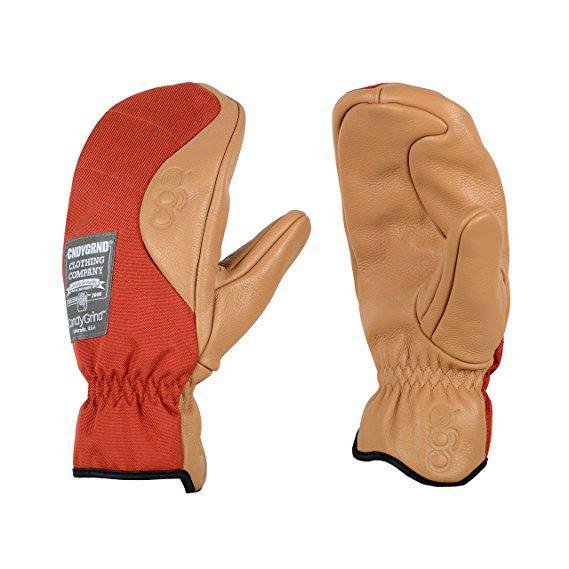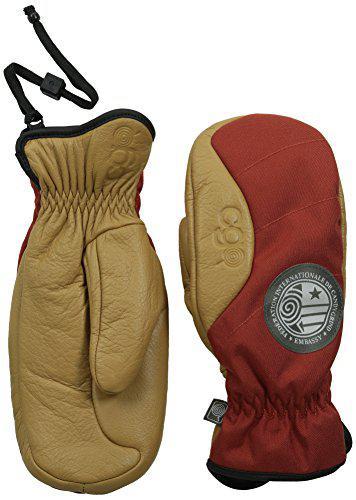The first image is the image on the left, the second image is the image on the right. Examine the images to the left and right. Is the description "Two pairs of mittens are shown in front and back views, but with only one pair is one thumb section extended to the side." accurate? Answer yes or no. Yes. The first image is the image on the left, the second image is the image on the right. For the images displayed, is the sentence "Each image shows the front and reverse sides of a pair of mittens, with the cuff opening at the bottom." factually correct? Answer yes or no. No. 